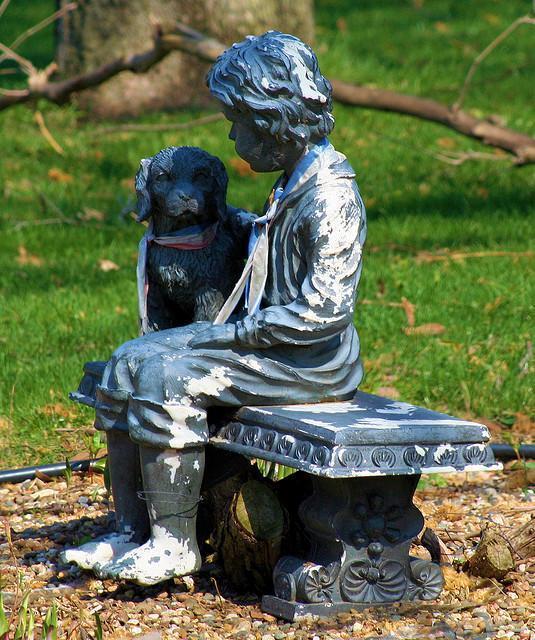How many bikes are there?
Give a very brief answer. 0. 